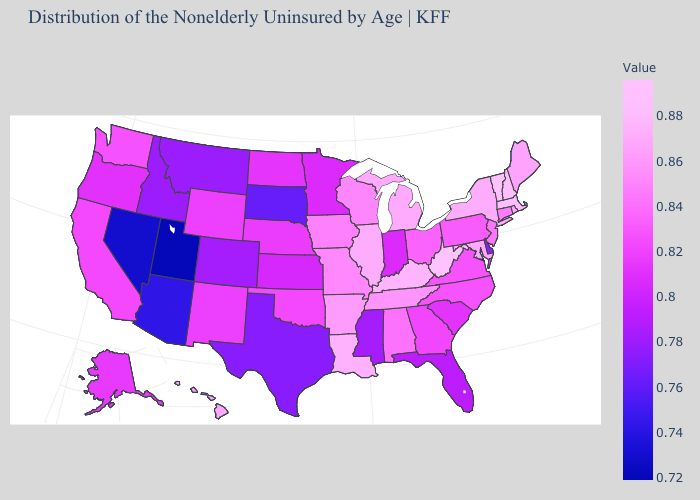Among the states that border Connecticut , does New York have the highest value?
Short answer required. No. Which states hav the highest value in the Northeast?
Write a very short answer. Vermont. Which states hav the highest value in the Northeast?
Quick response, please. Vermont. Among the states that border Florida , which have the lowest value?
Keep it brief. Georgia. Among the states that border Wyoming , does Utah have the lowest value?
Give a very brief answer. Yes. 